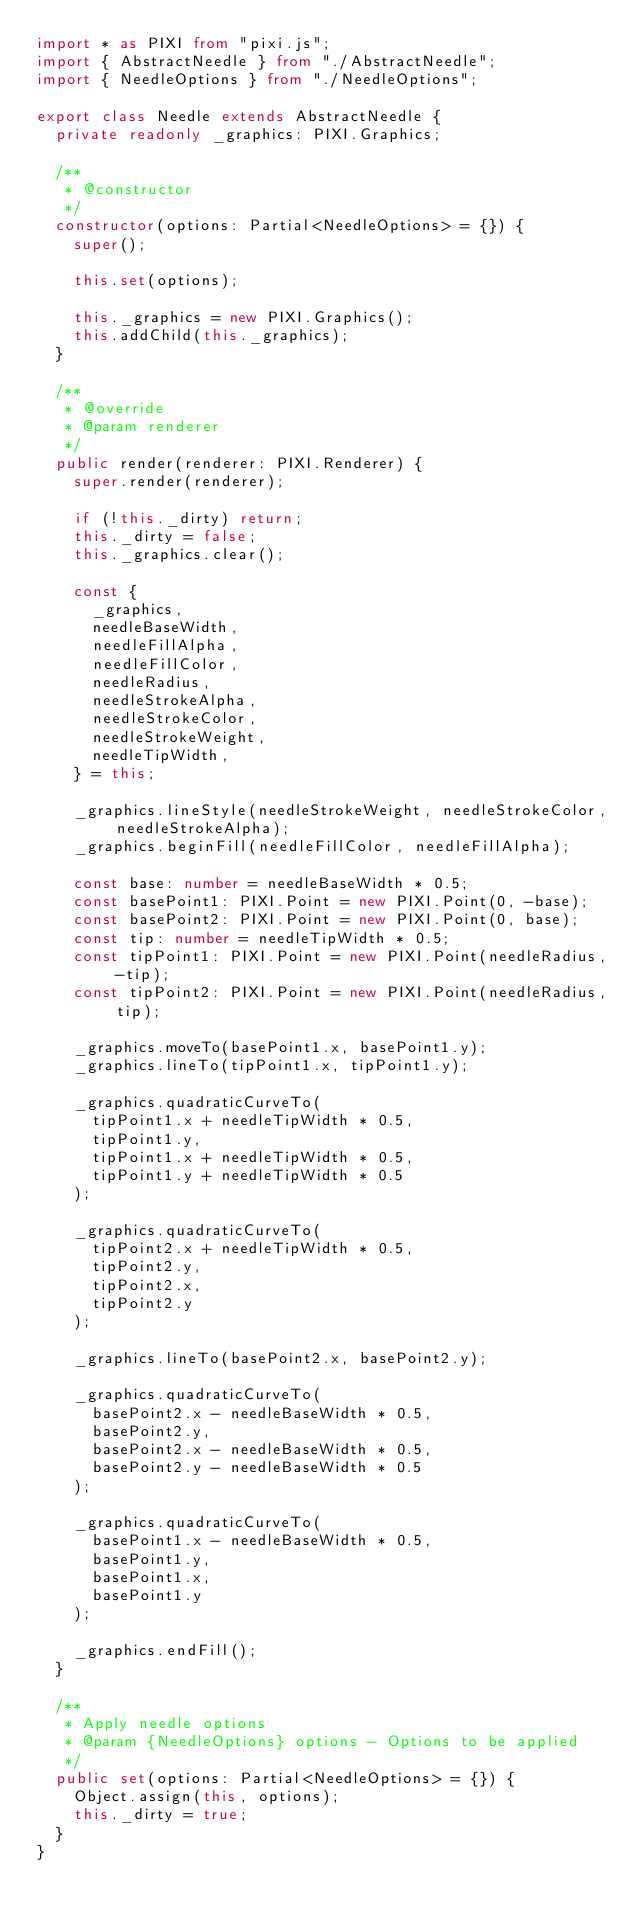Convert code to text. <code><loc_0><loc_0><loc_500><loc_500><_TypeScript_>import * as PIXI from "pixi.js";
import { AbstractNeedle } from "./AbstractNeedle";
import { NeedleOptions } from "./NeedleOptions";

export class Needle extends AbstractNeedle {
  private readonly _graphics: PIXI.Graphics;

  /**
   * @constructor
   */
  constructor(options: Partial<NeedleOptions> = {}) {
    super();

    this.set(options);

    this._graphics = new PIXI.Graphics();
    this.addChild(this._graphics);
  }

  /**
   * @override
   * @param renderer
   */
  public render(renderer: PIXI.Renderer) {
    super.render(renderer);

    if (!this._dirty) return;
    this._dirty = false;
    this._graphics.clear();

    const {
      _graphics,
      needleBaseWidth,
      needleFillAlpha,
      needleFillColor,
      needleRadius,
      needleStrokeAlpha,
      needleStrokeColor,
      needleStrokeWeight,
      needleTipWidth,
    } = this;

    _graphics.lineStyle(needleStrokeWeight, needleStrokeColor, needleStrokeAlpha);
    _graphics.beginFill(needleFillColor, needleFillAlpha);

    const base: number = needleBaseWidth * 0.5;
    const basePoint1: PIXI.Point = new PIXI.Point(0, -base);
    const basePoint2: PIXI.Point = new PIXI.Point(0, base);
    const tip: number = needleTipWidth * 0.5;
    const tipPoint1: PIXI.Point = new PIXI.Point(needleRadius, -tip);
    const tipPoint2: PIXI.Point = new PIXI.Point(needleRadius, tip);

    _graphics.moveTo(basePoint1.x, basePoint1.y);
    _graphics.lineTo(tipPoint1.x, tipPoint1.y);

    _graphics.quadraticCurveTo(
      tipPoint1.x + needleTipWidth * 0.5,
      tipPoint1.y,
      tipPoint1.x + needleTipWidth * 0.5,
      tipPoint1.y + needleTipWidth * 0.5
    );

    _graphics.quadraticCurveTo(
      tipPoint2.x + needleTipWidth * 0.5,
      tipPoint2.y,
      tipPoint2.x,
      tipPoint2.y
    );

    _graphics.lineTo(basePoint2.x, basePoint2.y);

    _graphics.quadraticCurveTo(
      basePoint2.x - needleBaseWidth * 0.5,
      basePoint2.y,
      basePoint2.x - needleBaseWidth * 0.5,
      basePoint2.y - needleBaseWidth * 0.5
    );

    _graphics.quadraticCurveTo(
      basePoint1.x - needleBaseWidth * 0.5,
      basePoint1.y,
      basePoint1.x,
      basePoint1.y
    );

    _graphics.endFill();
  }

  /**
   * Apply needle options
   * @param {NeedleOptions} options - Options to be applied
   */
  public set(options: Partial<NeedleOptions> = {}) {
    Object.assign(this, options);
    this._dirty = true;
  }
}
</code> 